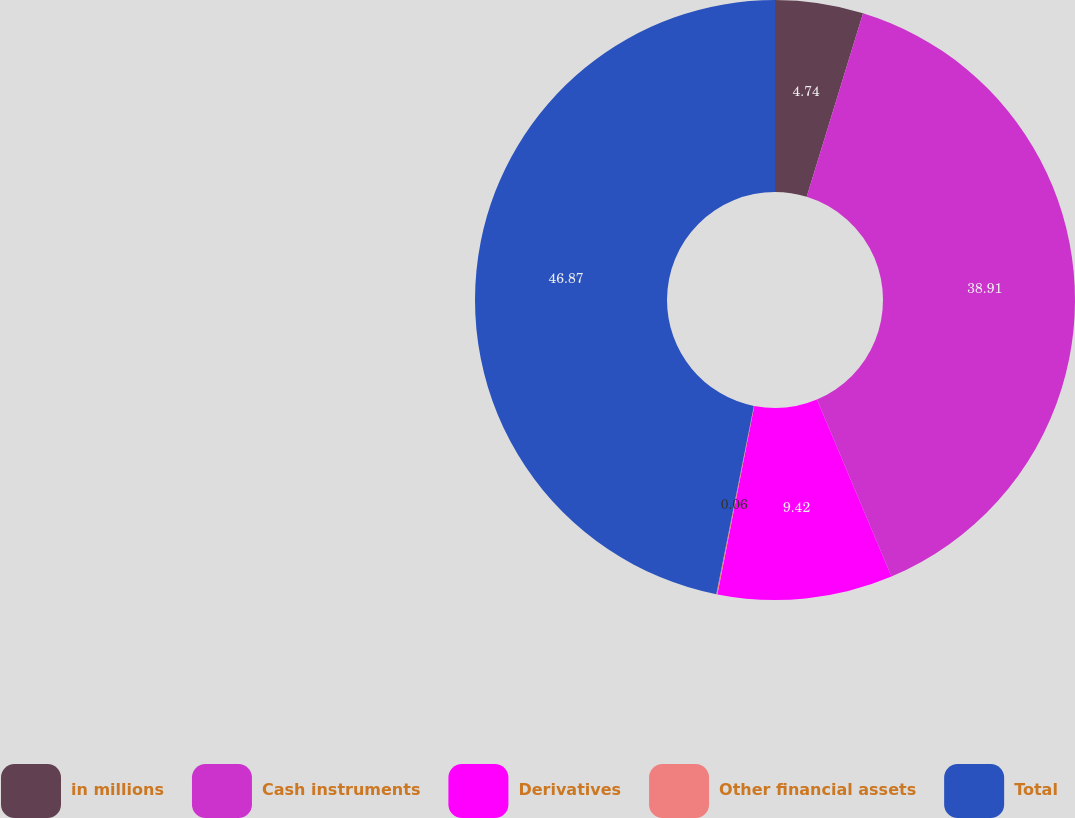Convert chart to OTSL. <chart><loc_0><loc_0><loc_500><loc_500><pie_chart><fcel>in millions<fcel>Cash instruments<fcel>Derivatives<fcel>Other financial assets<fcel>Total<nl><fcel>4.74%<fcel>38.91%<fcel>9.42%<fcel>0.06%<fcel>46.86%<nl></chart> 